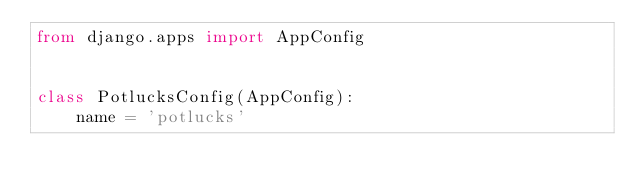Convert code to text. <code><loc_0><loc_0><loc_500><loc_500><_Python_>from django.apps import AppConfig


class PotlucksConfig(AppConfig):
    name = 'potlucks'
</code> 